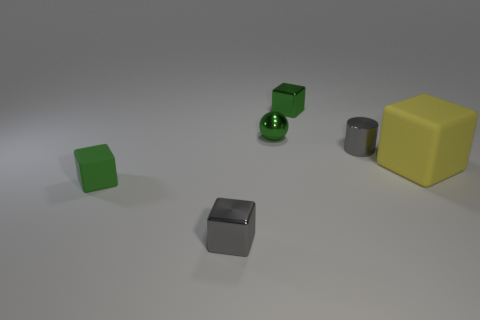What number of large matte things are left of the tiny ball?
Offer a very short reply. 0. There is another tiny rubber object that is the same shape as the yellow matte object; what color is it?
Provide a succinct answer. Green. Does the gray thing in front of the yellow matte cube have the same material as the green object that is in front of the small gray cylinder?
Give a very brief answer. No. There is a cylinder; does it have the same color as the object that is in front of the tiny matte object?
Provide a succinct answer. Yes. There is a thing that is to the right of the small green ball and in front of the tiny cylinder; what is its shape?
Your answer should be compact. Cube. What number of green matte cubes are there?
Provide a short and direct response. 1. What size is the green shiny thing that is the same shape as the yellow rubber thing?
Provide a succinct answer. Small. Is the shape of the tiny gray metal thing to the right of the gray shiny block the same as  the yellow thing?
Provide a short and direct response. No. There is a tiny metallic object behind the ball; what is its color?
Offer a very short reply. Green. What number of other objects are the same size as the metallic cylinder?
Ensure brevity in your answer.  4. 